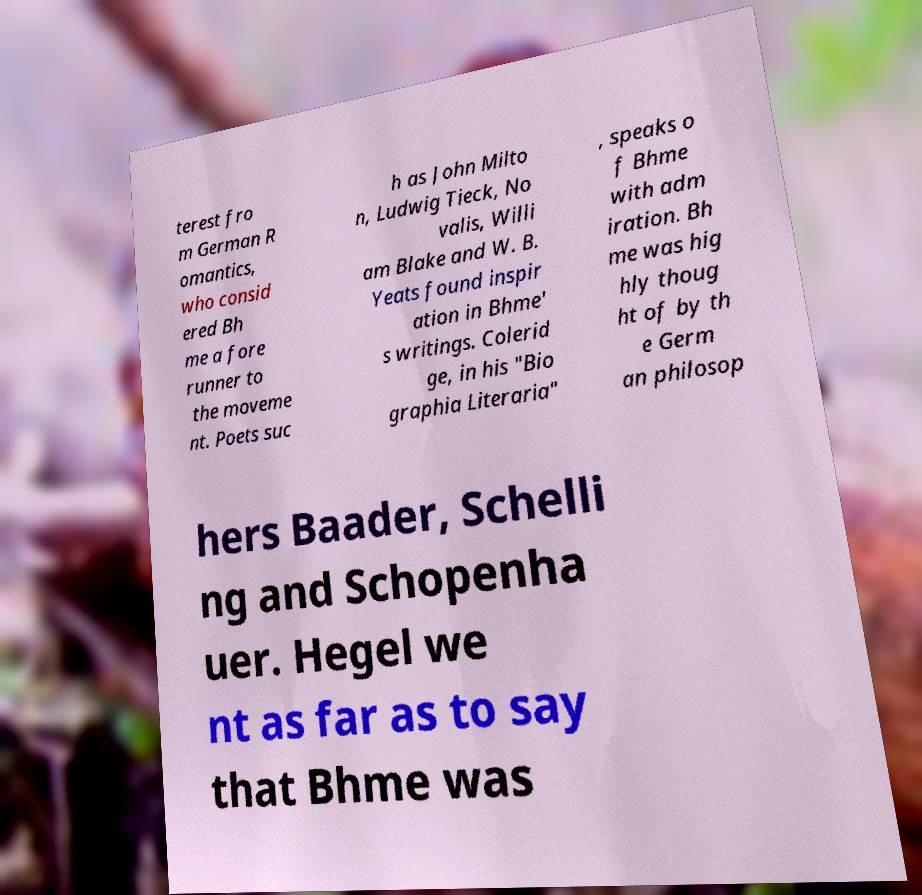Could you extract and type out the text from this image? terest fro m German R omantics, who consid ered Bh me a fore runner to the moveme nt. Poets suc h as John Milto n, Ludwig Tieck, No valis, Willi am Blake and W. B. Yeats found inspir ation in Bhme' s writings. Colerid ge, in his "Bio graphia Literaria" , speaks o f Bhme with adm iration. Bh me was hig hly thoug ht of by th e Germ an philosop hers Baader, Schelli ng and Schopenha uer. Hegel we nt as far as to say that Bhme was 